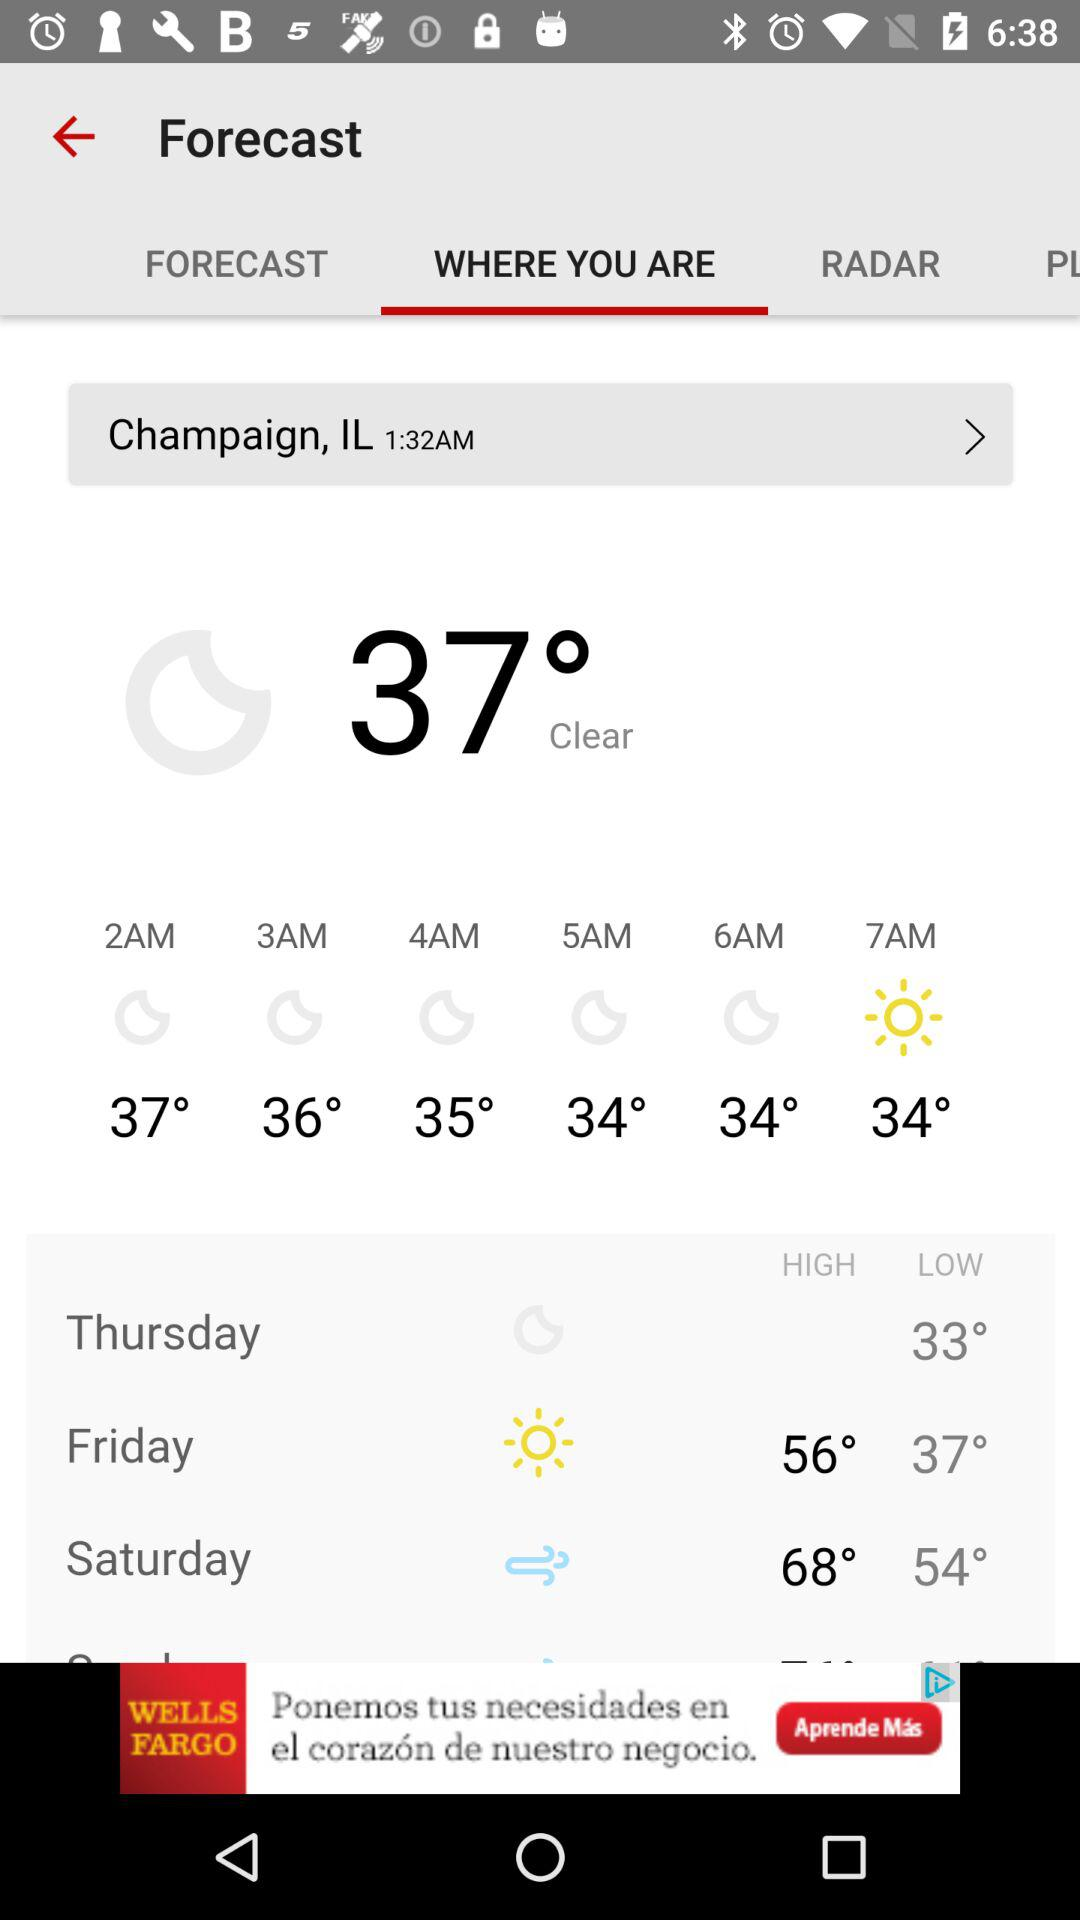On which day is the temperature 33 degrees? The temperature is 33 degrees on Thursday. 